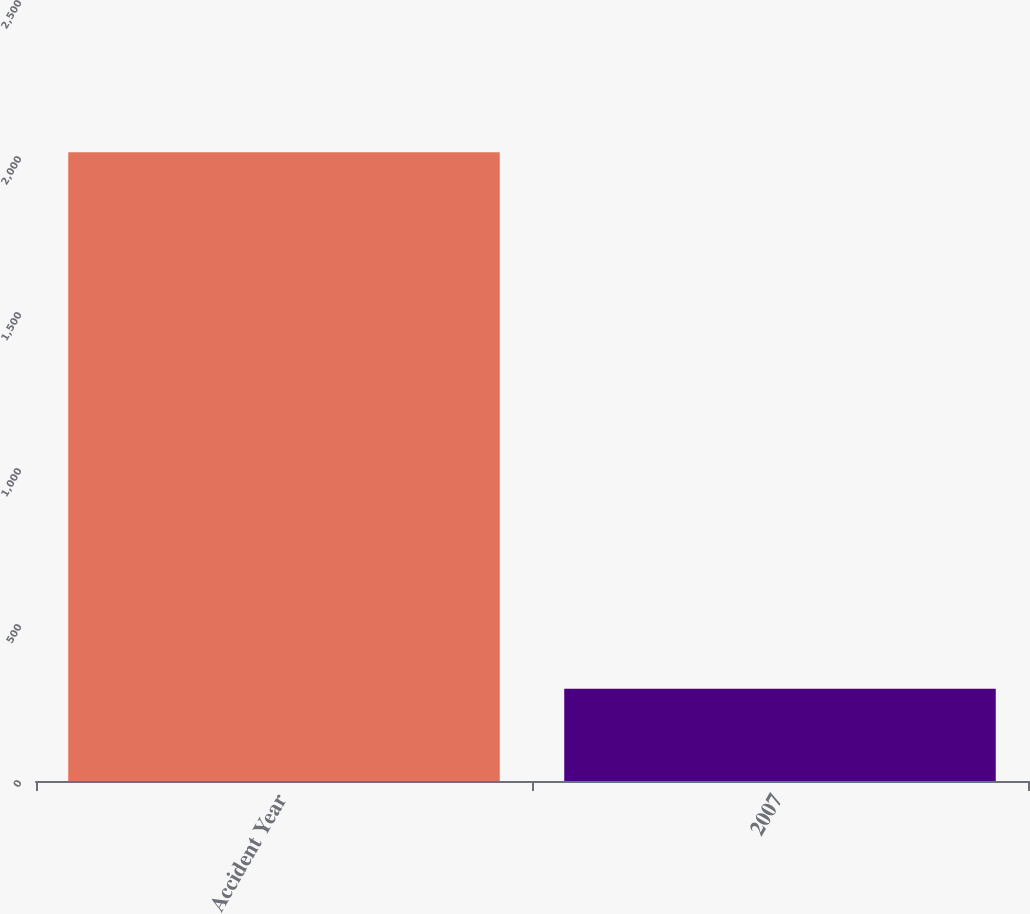Convert chart. <chart><loc_0><loc_0><loc_500><loc_500><bar_chart><fcel>Accident Year<fcel>2007<nl><fcel>2015<fcel>296<nl></chart> 